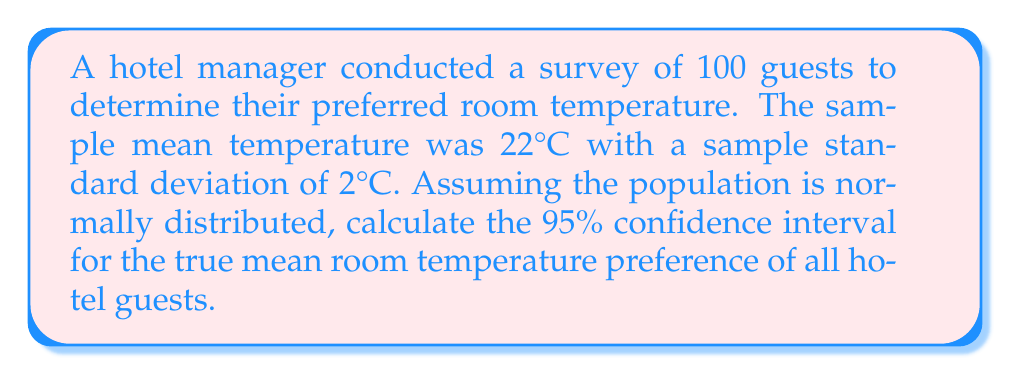Show me your answer to this math problem. To calculate the confidence interval, we'll use the formula:

$$\text{CI} = \bar{x} \pm t_{\alpha/2} \cdot \frac{s}{\sqrt{n}}$$

Where:
$\bar{x}$ = sample mean = 22°C
$s$ = sample standard deviation = 2°C
$n$ = sample size = 100
$t_{\alpha/2}$ = t-value for 95% confidence level with 99 degrees of freedom

Steps:
1) For a 95% confidence level and 99 degrees of freedom, $t_{\alpha/2} \approx 1.984$ (from t-distribution table)

2) Calculate the standard error:
   $$SE = \frac{s}{\sqrt{n}} = \frac{2}{\sqrt{100}} = 0.2$$

3) Calculate the margin of error:
   $$ME = t_{\alpha/2} \cdot SE = 1.984 \cdot 0.2 = 0.3968$$

4) Calculate the confidence interval:
   $$\text{CI} = 22 \pm 0.3968$$
   $$\text{CI} = (21.6032, 22.3968)$$

5) Round to one decimal place for practical use in temperature settings:
   $$\text{CI} = (21.6°C, 22.4°C)$$
Answer: (21.6°C, 22.4°C) 